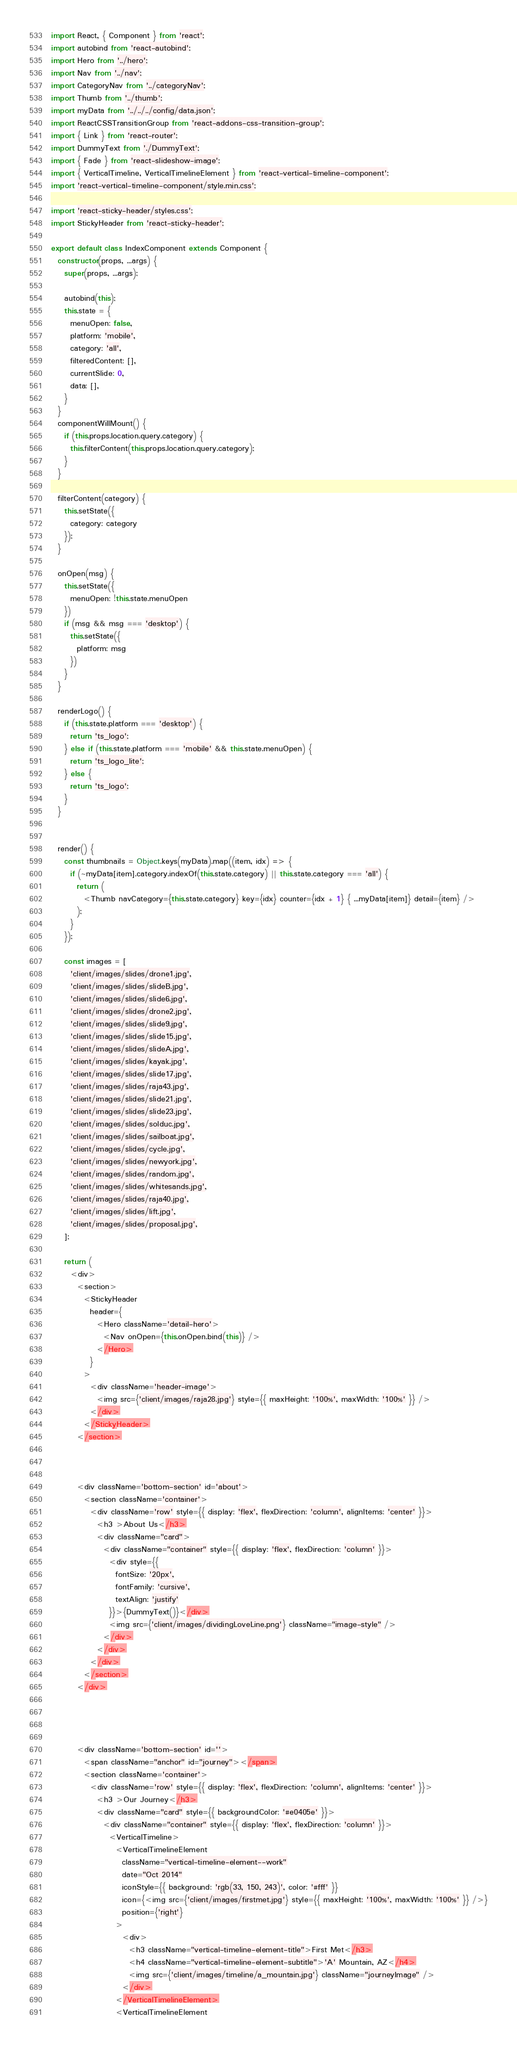Convert code to text. <code><loc_0><loc_0><loc_500><loc_500><_JavaScript_>import React, { Component } from 'react';
import autobind from 'react-autobind';
import Hero from '../hero';
import Nav from '../nav';
import CategoryNav from '../categoryNav';
import Thumb from '../thumb';
import myData from '../../../config/data.json';
import ReactCSSTransitionGroup from 'react-addons-css-transition-group';
import { Link } from 'react-router';
import DummyText from './DummyText';
import { Fade } from 'react-slideshow-image';
import { VerticalTimeline, VerticalTimelineElement } from 'react-vertical-timeline-component';
import 'react-vertical-timeline-component/style.min.css';

import 'react-sticky-header/styles.css';
import StickyHeader from 'react-sticky-header';

export default class IndexComponent extends Component {
  constructor(props, ...args) {
    super(props, ...args);

    autobind(this);
    this.state = {
      menuOpen: false,
      platform: 'mobile',
      category: 'all',
      filteredContent: [],
      currentSlide: 0,
      data: [],
    }
  }
  componentWillMount() {
    if (this.props.location.query.category) {
      this.filterContent(this.props.location.query.category);
    }
  }

  filterContent(category) {
    this.setState({
      category: category
    });
  }

  onOpen(msg) {
    this.setState({
      menuOpen: !this.state.menuOpen
    })
    if (msg && msg === 'desktop') {
      this.setState({
        platform: msg
      })
    }
  }

  renderLogo() {
    if (this.state.platform === 'desktop') {
      return 'ts_logo';
    } else if (this.state.platform === 'mobile' && this.state.menuOpen) {
      return 'ts_logo_lite';
    } else {
      return 'ts_logo';
    }
  }


  render() {
    const thumbnails = Object.keys(myData).map((item, idx) => {
      if (~myData[item].category.indexOf(this.state.category) || this.state.category === 'all') {
        return (
          <Thumb navCategory={this.state.category} key={idx} counter={idx + 1} { ...myData[item]} detail={item} />
        );
      }
    });

    const images = [
      'client/images/slides/drone1.jpg',
      'client/images/slides/slideB.jpg',
      'client/images/slides/slide6.jpg',
      'client/images/slides/drone2.jpg',
      'client/images/slides/slide9.jpg',
      'client/images/slides/slide15.jpg',
      'client/images/slides/slideA.jpg',
      'client/images/slides/kayak.jpg',
      'client/images/slides/slide17.jpg',
      'client/images/slides/raja43.jpg',
      'client/images/slides/slide21.jpg',
      'client/images/slides/slide23.jpg',
      'client/images/slides/solduc.jpg',
      'client/images/slides/sailboat.jpg',
      'client/images/slides/cycle.jpg',
      'client/images/slides/newyork.jpg',
      'client/images/slides/random.jpg',
      'client/images/slides/whitesands.jpg',
      'client/images/slides/raja40.jpg',
      'client/images/slides/lift.jpg',
      'client/images/slides/proposal.jpg',
    ];

    return (
      <div>
        <section>
          <StickyHeader
            header={
              <Hero className='detail-hero'>
                <Nav onOpen={this.onOpen.bind(this)} />
              </Hero>
            }
          >
            <div className='header-image'>
              <img src={'client/images/raja28.jpg'} style={{ maxHeight: '100%', maxWidth: '100%' }} />
            </div>
          </StickyHeader>
        </section>



        <div className='bottom-section' id='about'>
          <section className='container'>
            <div className='row' style={{ display: 'flex', flexDirection: 'column', alignItems: 'center' }}>
              <h3 >About Us</h3>
              <div className="card">
                <div className="container" style={{ display: 'flex', flexDirection: 'column' }}>
                  <div style={{
                    fontSize: '20px',
                    fontFamily: 'cursive',
                    textAlign: 'justify'
                  }}>{DummyText()}</div>
                  <img src={'client/images/dividingLoveLine.png'} className="image-style" />
                </div>
              </div>
            </div>
          </section>
        </div>




        <div className='bottom-section' id=''>
          <span className="anchor" id="journey"></span>
          <section className='container'>
            <div className='row' style={{ display: 'flex', flexDirection: 'column', alignItems: 'center' }}>
              <h3 >Our Journey</h3>
              <div className="card" style={{ backgroundColor: '#e0405e' }}>
                <div className="container" style={{ display: 'flex', flexDirection: 'column' }}>
                  <VerticalTimeline>
                    <VerticalTimelineElement
                      className="vertical-timeline-element--work"
                      date="Oct 2014"
                      iconStyle={{ background: 'rgb(33, 150, 243)', color: '#fff' }}
                      icon={<img src={'client/images/firstmet.jpg'} style={{ maxHeight: '100%', maxWidth: '100%' }} />}
                      position={'right'}
                    >
                      <div>
                        <h3 className="vertical-timeline-element-title">First Met</h3>
                        <h4 className="vertical-timeline-element-subtitle">'A' Mountain, AZ</h4>
                        <img src={'client/images/timeline/a_mountain.jpg'} className="journeyImage" />
                      </div>
                    </VerticalTimelineElement>
                    <VerticalTimelineElement</code> 